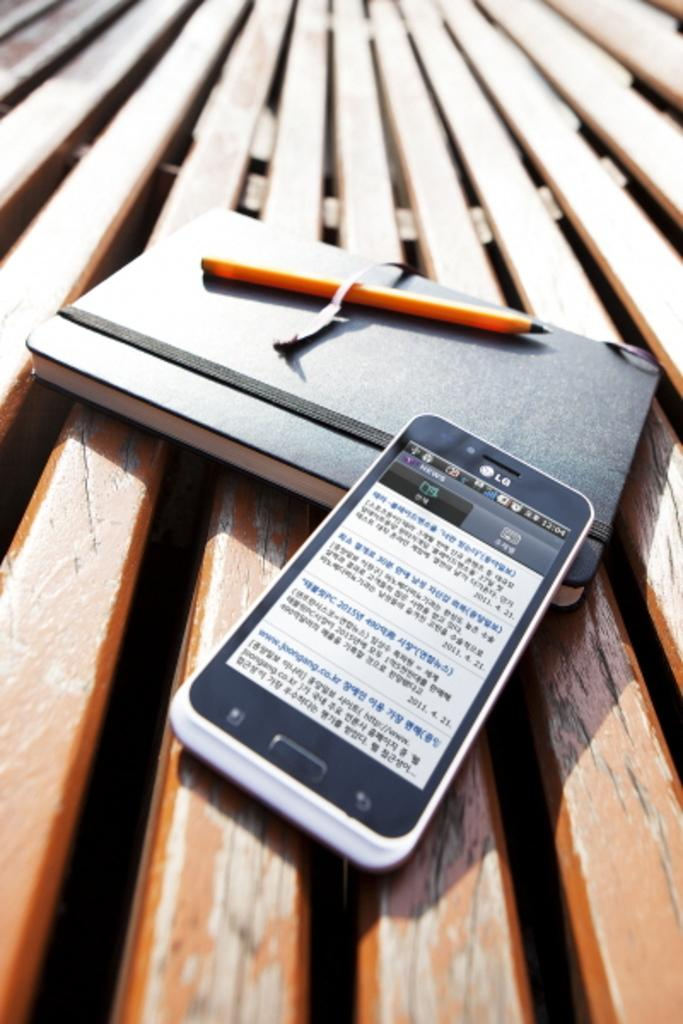What electronic device is visible in the image? There is a mobile phone in the image. What type of reading material is present in the image? There is a book in the image. What writing instrument is visible in the image? There is a pen in the image. What is the surface made of that the objects are placed on? The objects are placed on a wooden surface. What type of veil is draped over the mobile phone in the image? There is no veil present in the image; the mobile phone is not covered by any fabric. 